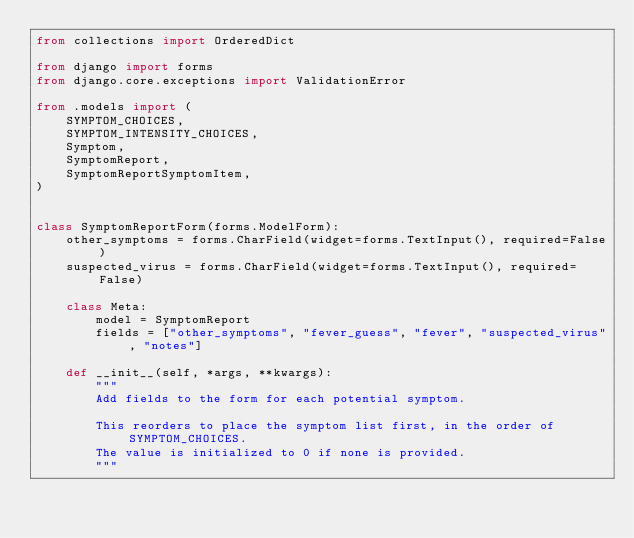Convert code to text. <code><loc_0><loc_0><loc_500><loc_500><_Python_>from collections import OrderedDict

from django import forms
from django.core.exceptions import ValidationError

from .models import (
    SYMPTOM_CHOICES,
    SYMPTOM_INTENSITY_CHOICES,
    Symptom,
    SymptomReport,
    SymptomReportSymptomItem,
)


class SymptomReportForm(forms.ModelForm):
    other_symptoms = forms.CharField(widget=forms.TextInput(), required=False)
    suspected_virus = forms.CharField(widget=forms.TextInput(), required=False)

    class Meta:
        model = SymptomReport
        fields = ["other_symptoms", "fever_guess", "fever", "suspected_virus", "notes"]

    def __init__(self, *args, **kwargs):
        """
        Add fields to the form for each potential symptom.

        This reorders to place the symptom list first, in the order of SYMPTOM_CHOICES.
        The value is initialized to 0 if none is provided.
        """</code> 